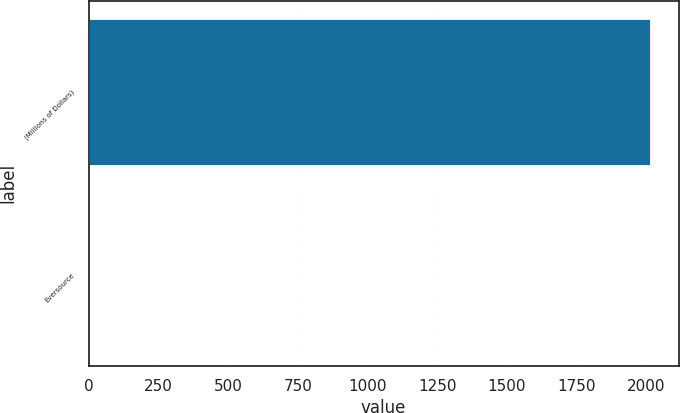Convert chart to OTSL. <chart><loc_0><loc_0><loc_500><loc_500><bar_chart><fcel>(Millions of Dollars)<fcel>Eversource<nl><fcel>2015<fcel>2<nl></chart> 